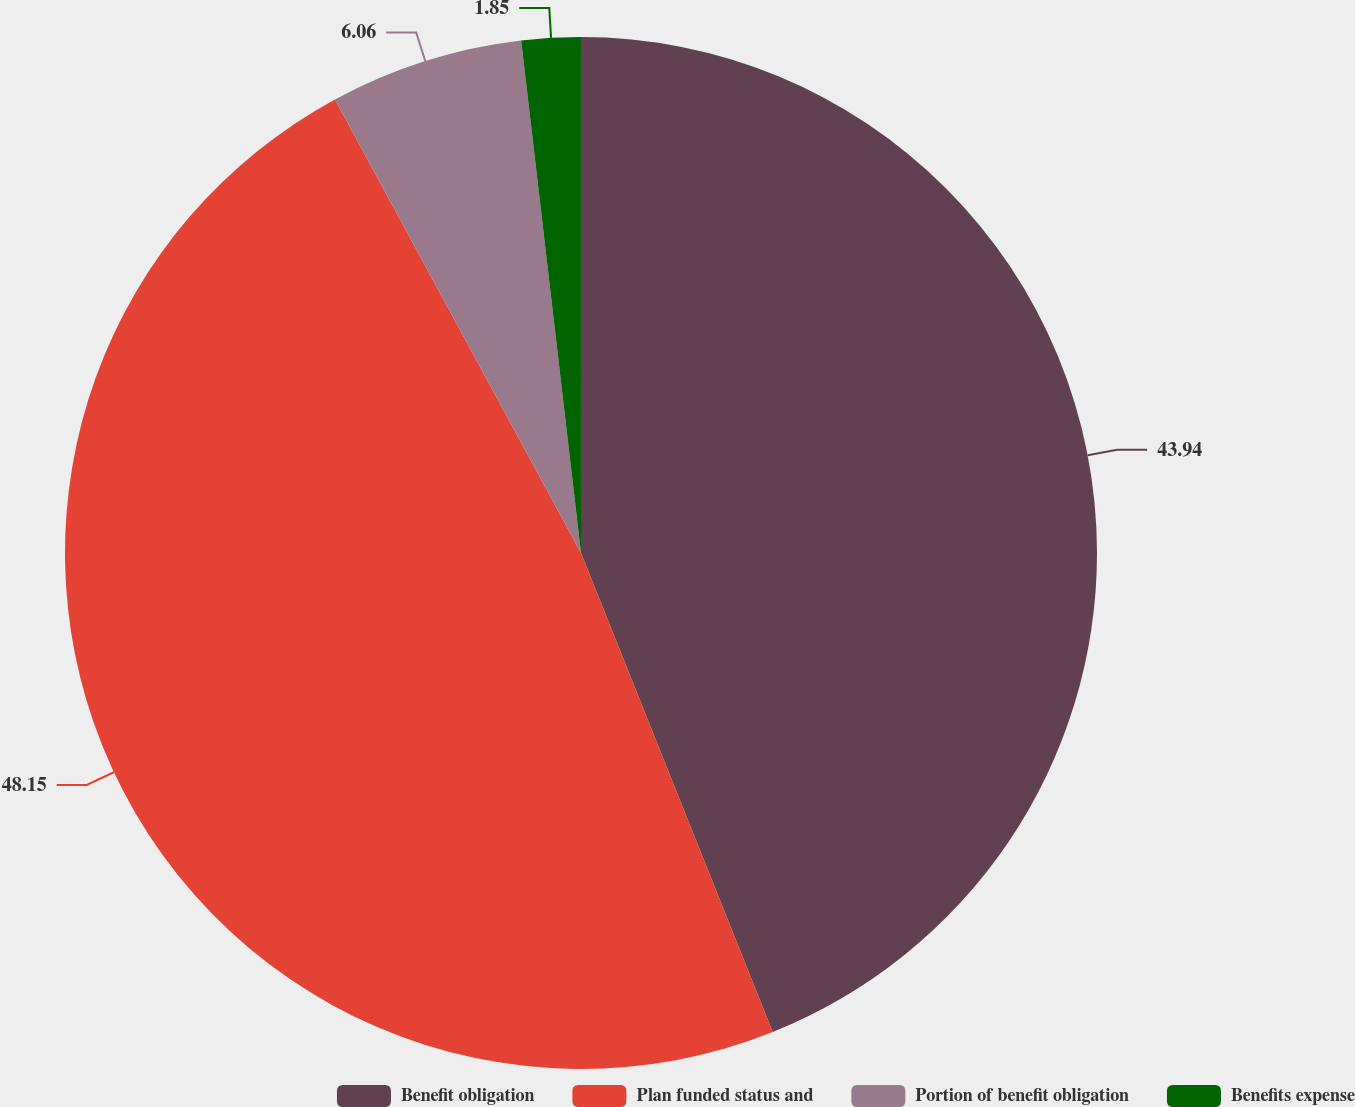Convert chart. <chart><loc_0><loc_0><loc_500><loc_500><pie_chart><fcel>Benefit obligation<fcel>Plan funded status and<fcel>Portion of benefit obligation<fcel>Benefits expense<nl><fcel>43.94%<fcel>48.15%<fcel>6.06%<fcel>1.85%<nl></chart> 